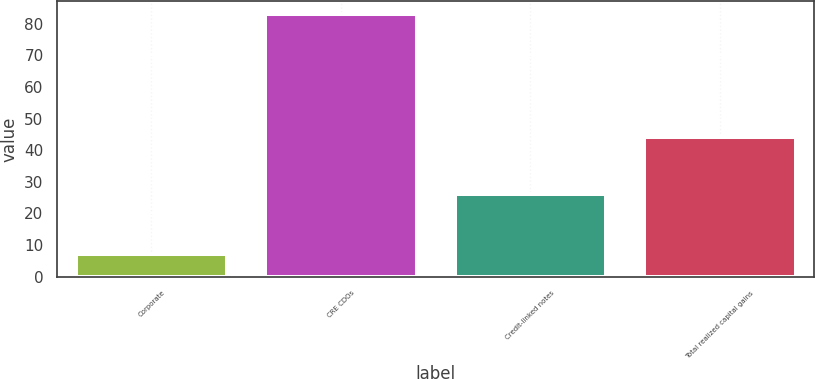Convert chart to OTSL. <chart><loc_0><loc_0><loc_500><loc_500><bar_chart><fcel>Corporate<fcel>CRE CDOs<fcel>Credit-linked notes<fcel>Total realized capital gains<nl><fcel>7<fcel>83<fcel>26<fcel>44<nl></chart> 